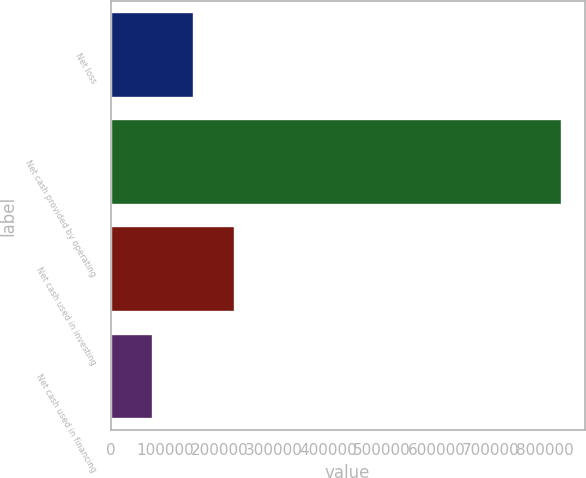<chart> <loc_0><loc_0><loc_500><loc_500><bar_chart><fcel>Net loss<fcel>Net cash provided by operating<fcel>Net cash used in investing<fcel>Net cash used in financing<nl><fcel>153657<fcel>831209<fcel>228940<fcel>78373<nl></chart> 